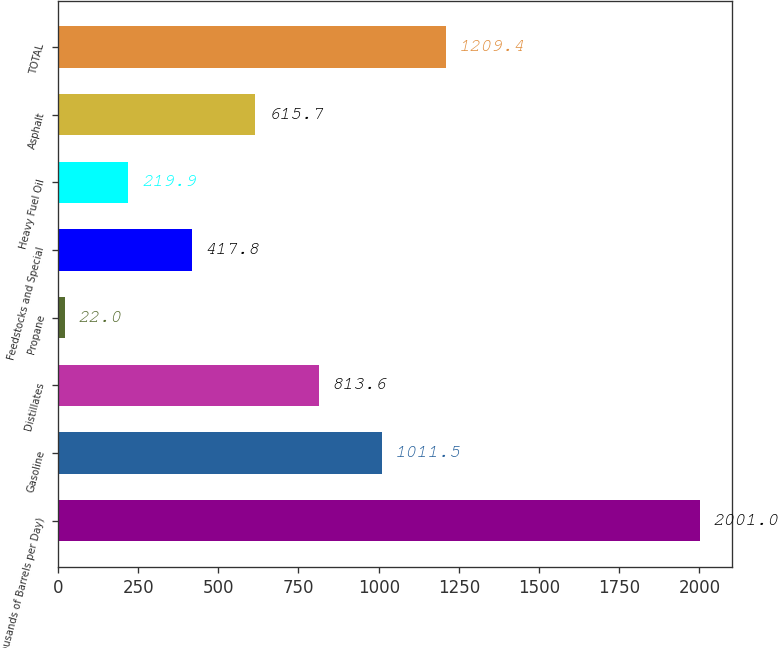<chart> <loc_0><loc_0><loc_500><loc_500><bar_chart><fcel>(Thousands of Barrels per Day)<fcel>Gasoline<fcel>Distillates<fcel>Propane<fcel>Feedstocks and Special<fcel>Heavy Fuel Oil<fcel>Asphalt<fcel>TOTAL<nl><fcel>2001<fcel>1011.5<fcel>813.6<fcel>22<fcel>417.8<fcel>219.9<fcel>615.7<fcel>1209.4<nl></chart> 